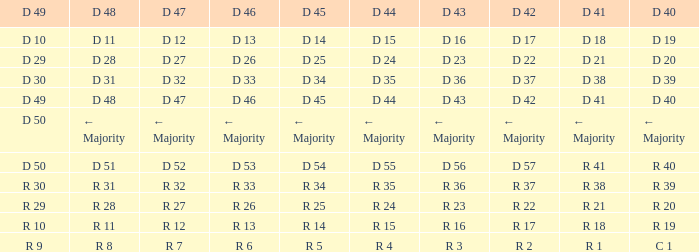I desire the d 45 and d 42 of r 22 R 25. 